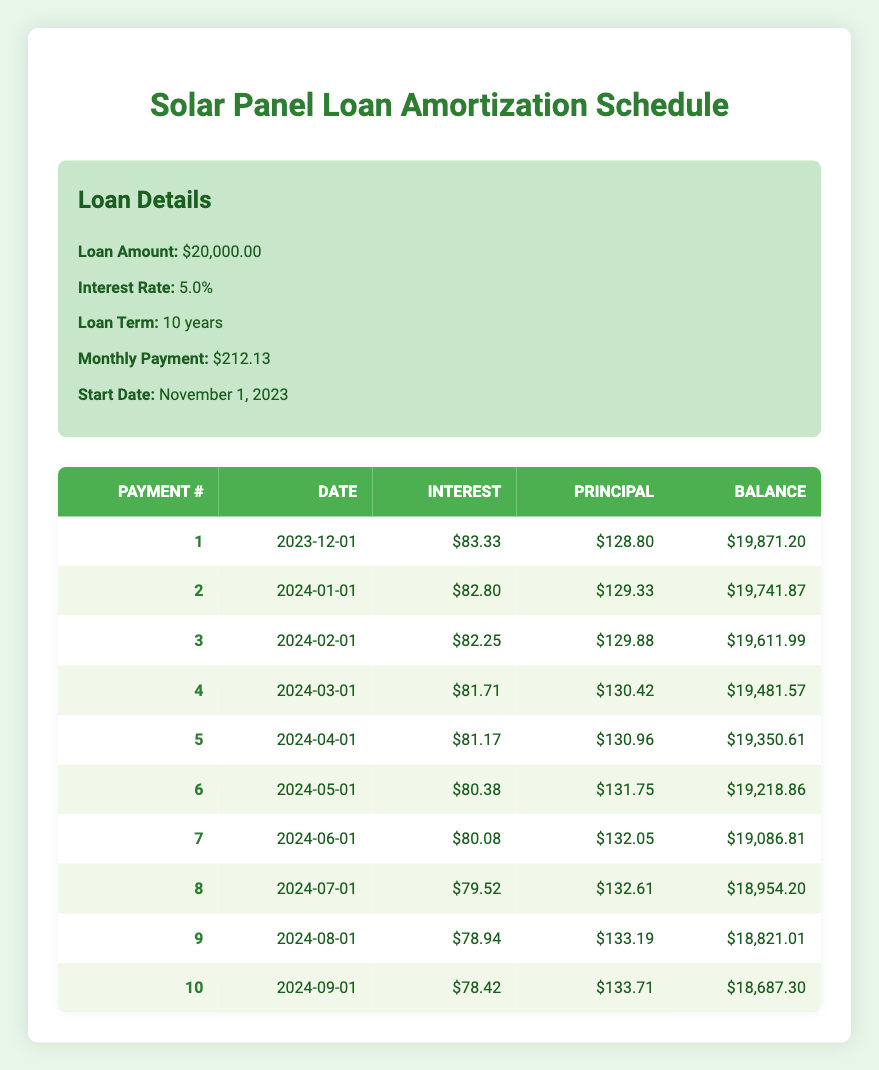What is the total interest paid in the first payment? The interest payment for the first payment as shown in the table is 83.33.
Answer: 83.33 What is the remaining balance after the 5th payment? The remaining balance after the 5th payment, according to the table, is 19,350.61.
Answer: 19,350.61 What is the total principal paid after the first three payments? The principal payments for the first three payments are 128.80 (1st) + 129.33 (2nd) + 129.88 (3rd) = 388.01 total.
Answer: 388.01 Is the interest payment in the 7th month greater than 80? The interest payment for the 7th payment is 80.08, which is indeed greater than 80.
Answer: Yes What is the average monthly principal payment over the first ten payments? The principal payments for the first ten payments can be summed: (128.80 + 129.33 + 129.88 + 130.42 + 130.96 + 131.75 + 132.05 + 132.61 + 133.19 + 133.71 = 1,306.60), and divided by 10 gives an average of 130.66.
Answer: 130.66 How much has the remaining balance decreased after the first four payments? The remaining balance after the 4th payment is 19,481.57 and after the 1st payment it was 19,871.20. The decrease is 19,871.20 - 19,481.57 = 389.63.
Answer: 389.63 Is the monthly payment consistent throughout the loan term? The monthly payment amount listed is 212.13, and since that amount remains unchanged throughout the term, the answer is yes.
Answer: Yes What is the remaining balance after the 10th payment? The remaining balance after the 10th payment is stated in the table as 18,687.30.
Answer: 18,687.30 Which month has the highest principal payment in the first ten payments? By reviewing the principal payments for the first ten payments, 133.71 (10th payment) is the highest.
Answer: 10th payment What will be the total interest paid by the end of the loan term? To find the total interest paid, sum all interest payments over the ten months (83.33 + 82.80 + 82.25 + ... + 78.42) which equals 804.43.
Answer: 804.43 